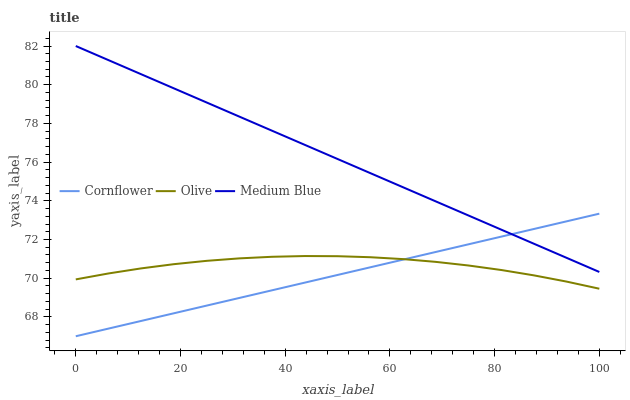Does Cornflower have the minimum area under the curve?
Answer yes or no. Yes. Does Medium Blue have the maximum area under the curve?
Answer yes or no. Yes. Does Medium Blue have the minimum area under the curve?
Answer yes or no. No. Does Cornflower have the maximum area under the curve?
Answer yes or no. No. Is Cornflower the smoothest?
Answer yes or no. Yes. Is Olive the roughest?
Answer yes or no. Yes. Is Medium Blue the smoothest?
Answer yes or no. No. Is Medium Blue the roughest?
Answer yes or no. No. Does Cornflower have the lowest value?
Answer yes or no. Yes. Does Medium Blue have the lowest value?
Answer yes or no. No. Does Medium Blue have the highest value?
Answer yes or no. Yes. Does Cornflower have the highest value?
Answer yes or no. No. Is Olive less than Medium Blue?
Answer yes or no. Yes. Is Medium Blue greater than Olive?
Answer yes or no. Yes. Does Olive intersect Cornflower?
Answer yes or no. Yes. Is Olive less than Cornflower?
Answer yes or no. No. Is Olive greater than Cornflower?
Answer yes or no. No. Does Olive intersect Medium Blue?
Answer yes or no. No. 